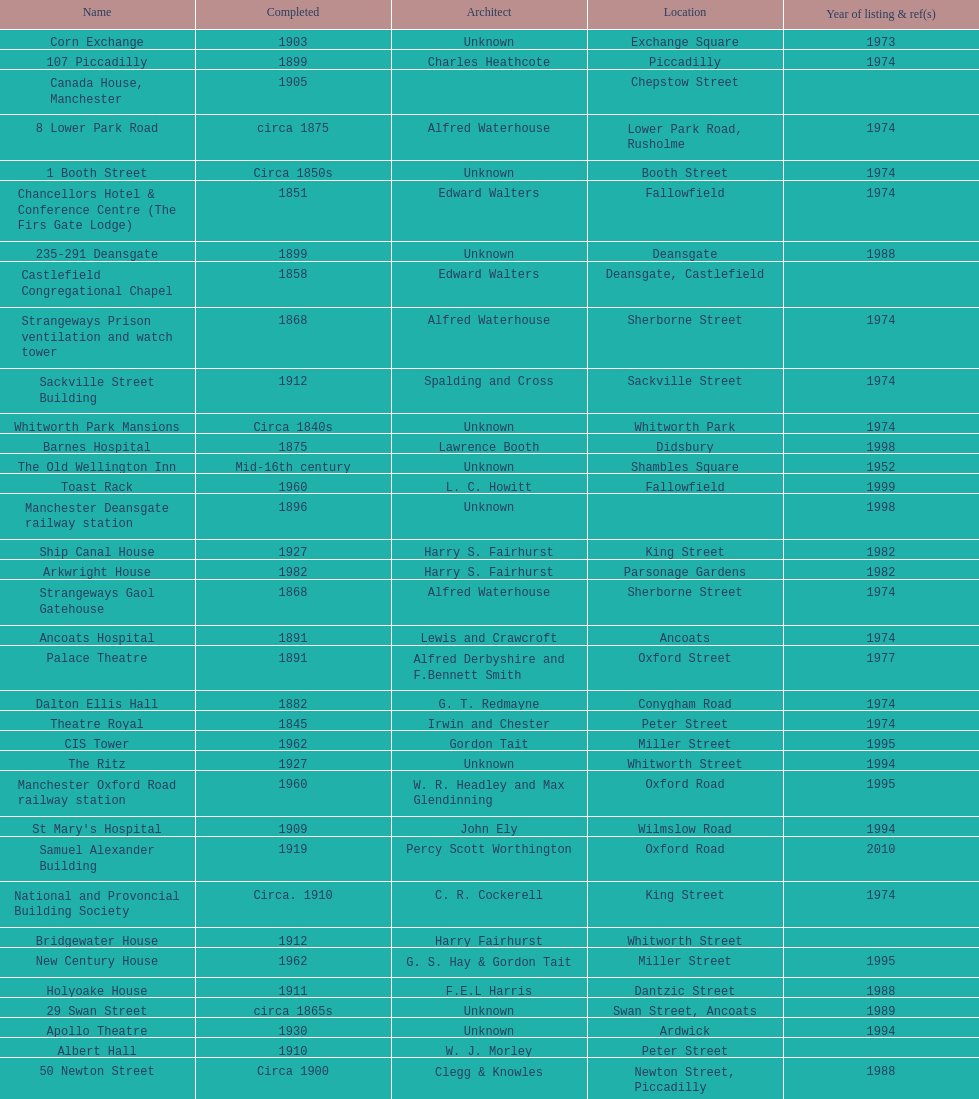How many buildings has the same year of listing as 1974? 15. 